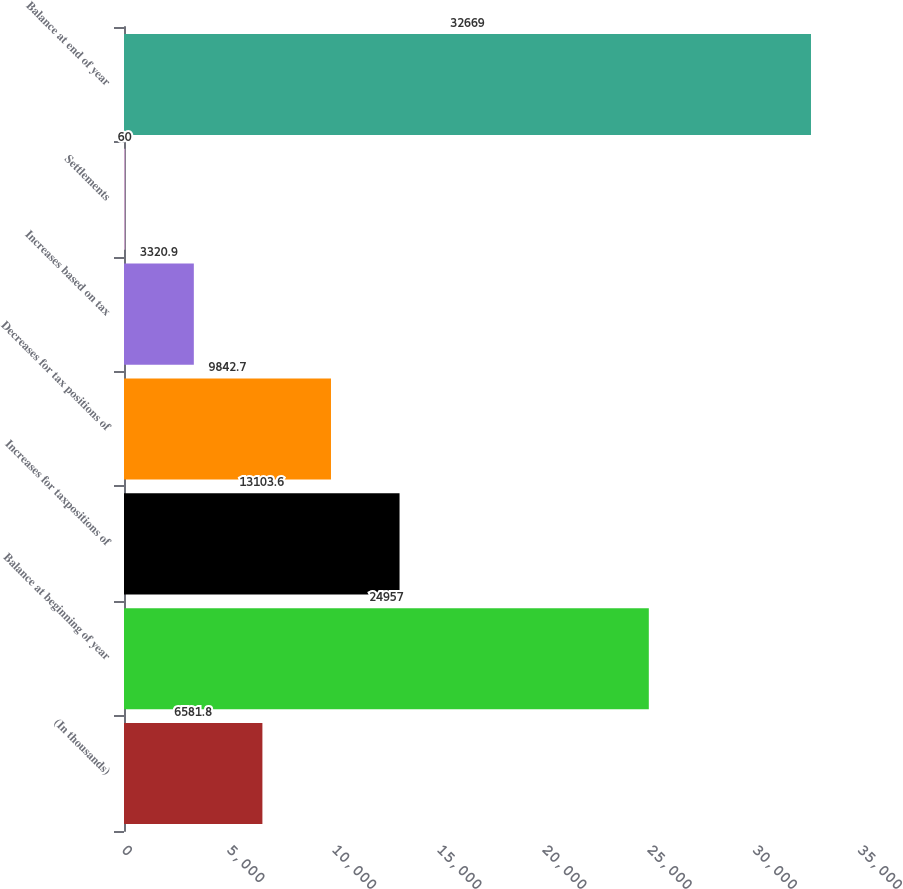<chart> <loc_0><loc_0><loc_500><loc_500><bar_chart><fcel>(In thousands)<fcel>Balance at beginning of year<fcel>Increases for taxpositions of<fcel>Decreases for tax positions of<fcel>Increases based on tax<fcel>Settlements<fcel>Balance at end of year<nl><fcel>6581.8<fcel>24957<fcel>13103.6<fcel>9842.7<fcel>3320.9<fcel>60<fcel>32669<nl></chart> 